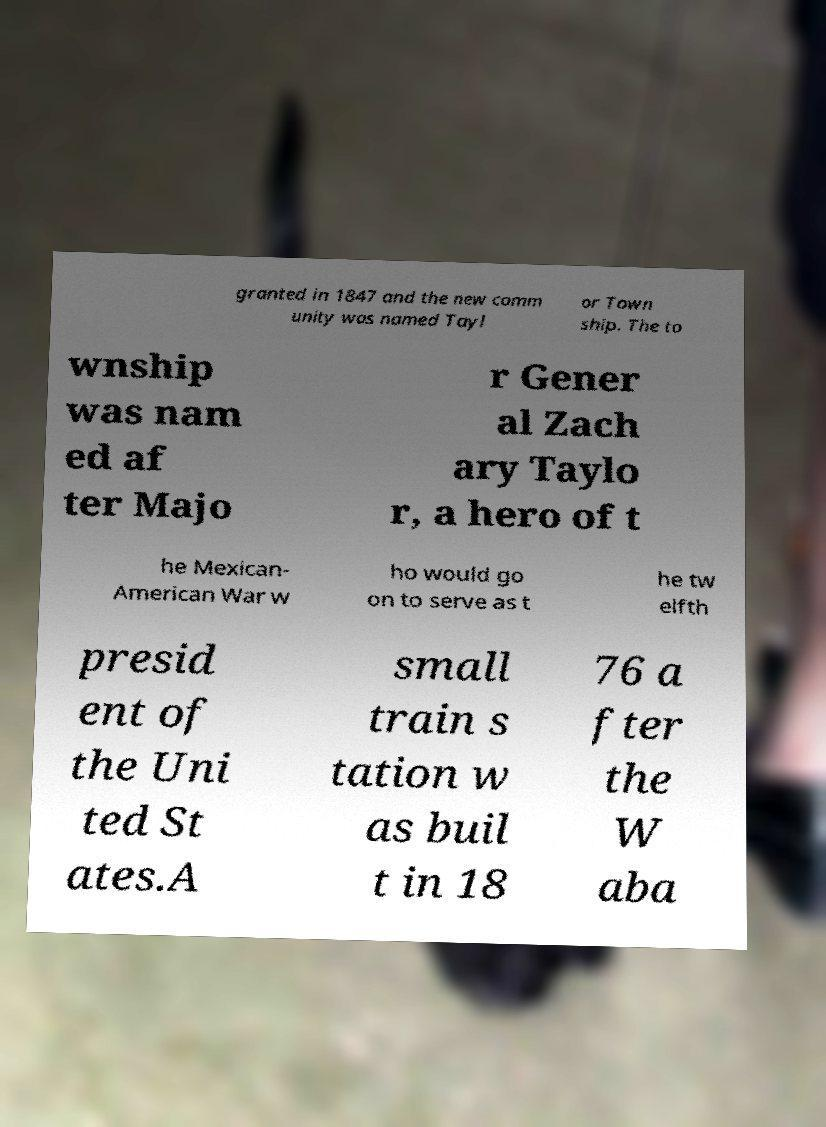For documentation purposes, I need the text within this image transcribed. Could you provide that? granted in 1847 and the new comm unity was named Tayl or Town ship. The to wnship was nam ed af ter Majo r Gener al Zach ary Taylo r, a hero of t he Mexican- American War w ho would go on to serve as t he tw elfth presid ent of the Uni ted St ates.A small train s tation w as buil t in 18 76 a fter the W aba 